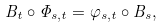Convert formula to latex. <formula><loc_0><loc_0><loc_500><loc_500>B _ { t } \circ \Phi _ { s , t } = \varphi _ { s , t } \circ B _ { s } ,</formula> 